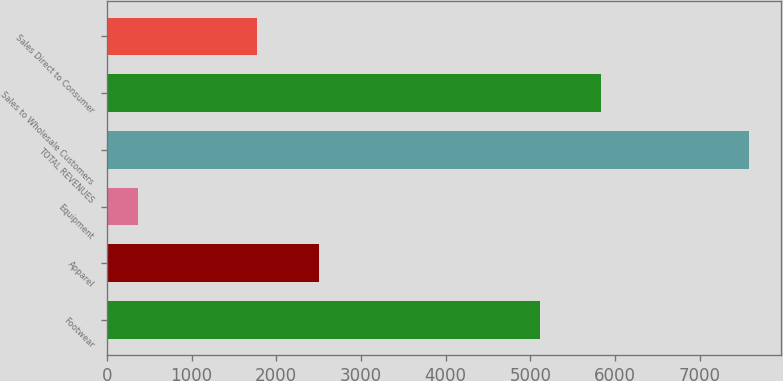Convert chart to OTSL. <chart><loc_0><loc_0><loc_500><loc_500><bar_chart><fcel>Footwear<fcel>Apparel<fcel>Equipment<fcel>TOTAL REVENUES<fcel>Sales to Wholesale Customers<fcel>Sales Direct to Consumer<nl><fcel>5111<fcel>2499.4<fcel>365<fcel>7579<fcel>5832.4<fcel>1778<nl></chart> 